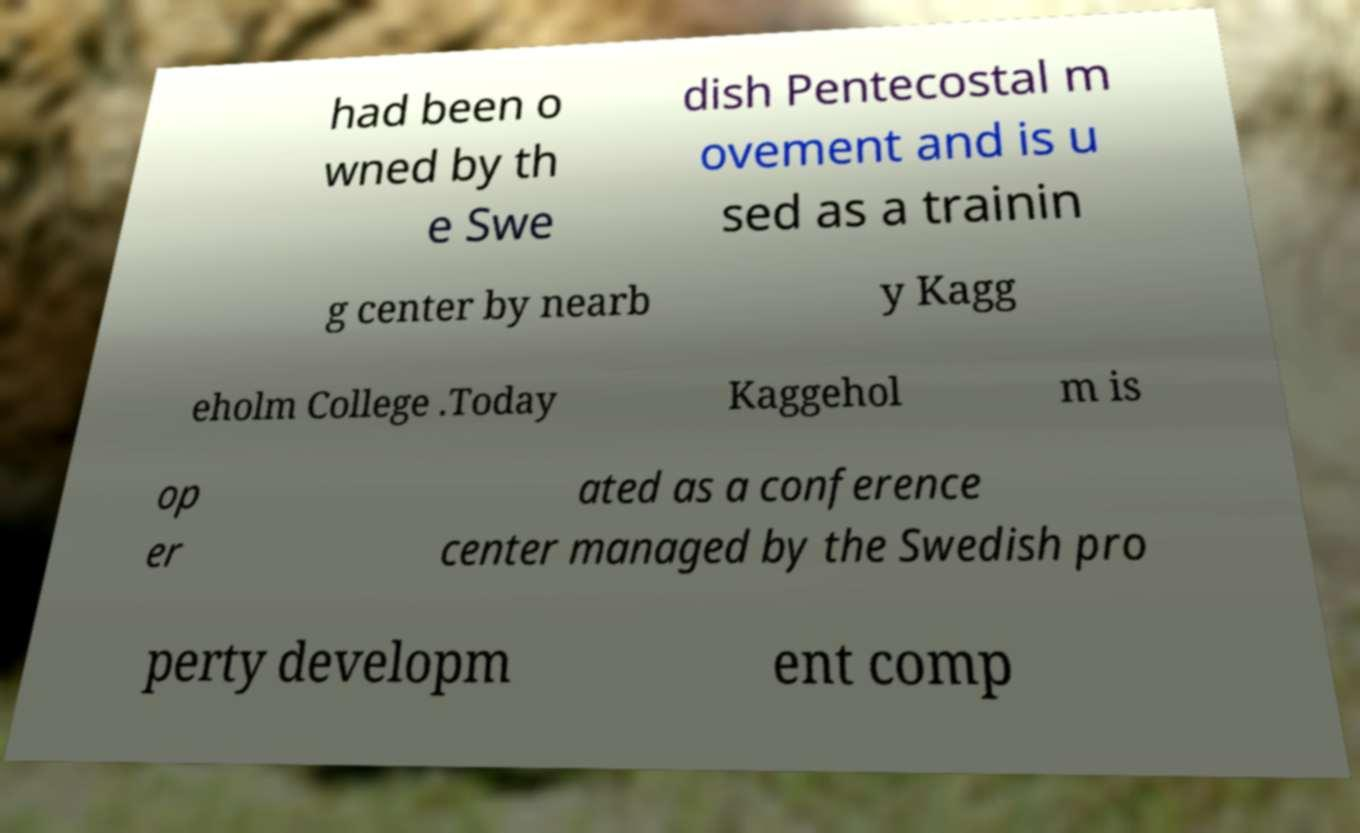I need the written content from this picture converted into text. Can you do that? had been o wned by th e Swe dish Pentecostal m ovement and is u sed as a trainin g center by nearb y Kagg eholm College .Today Kaggehol m is op er ated as a conference center managed by the Swedish pro perty developm ent comp 